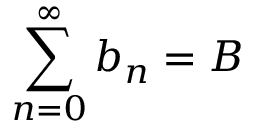Convert formula to latex. <formula><loc_0><loc_0><loc_500><loc_500>\sum _ { n = 0 } ^ { \infty } b _ { n } = B</formula> 